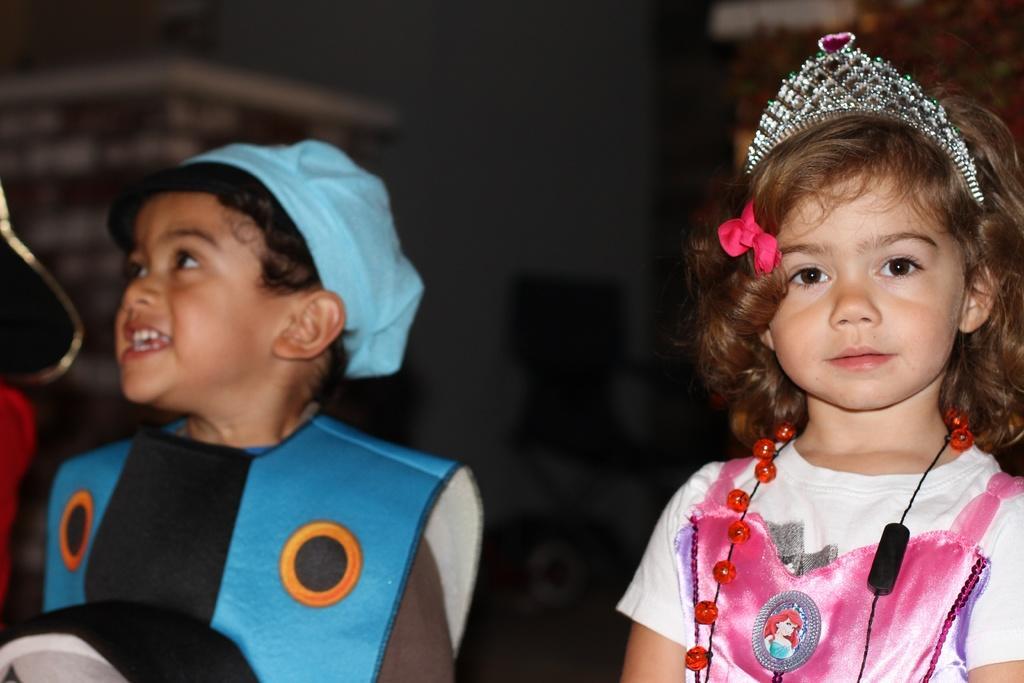How would you summarize this image in a sentence or two? In this image we can see kids and in the background the image is blur but we can see objects. 